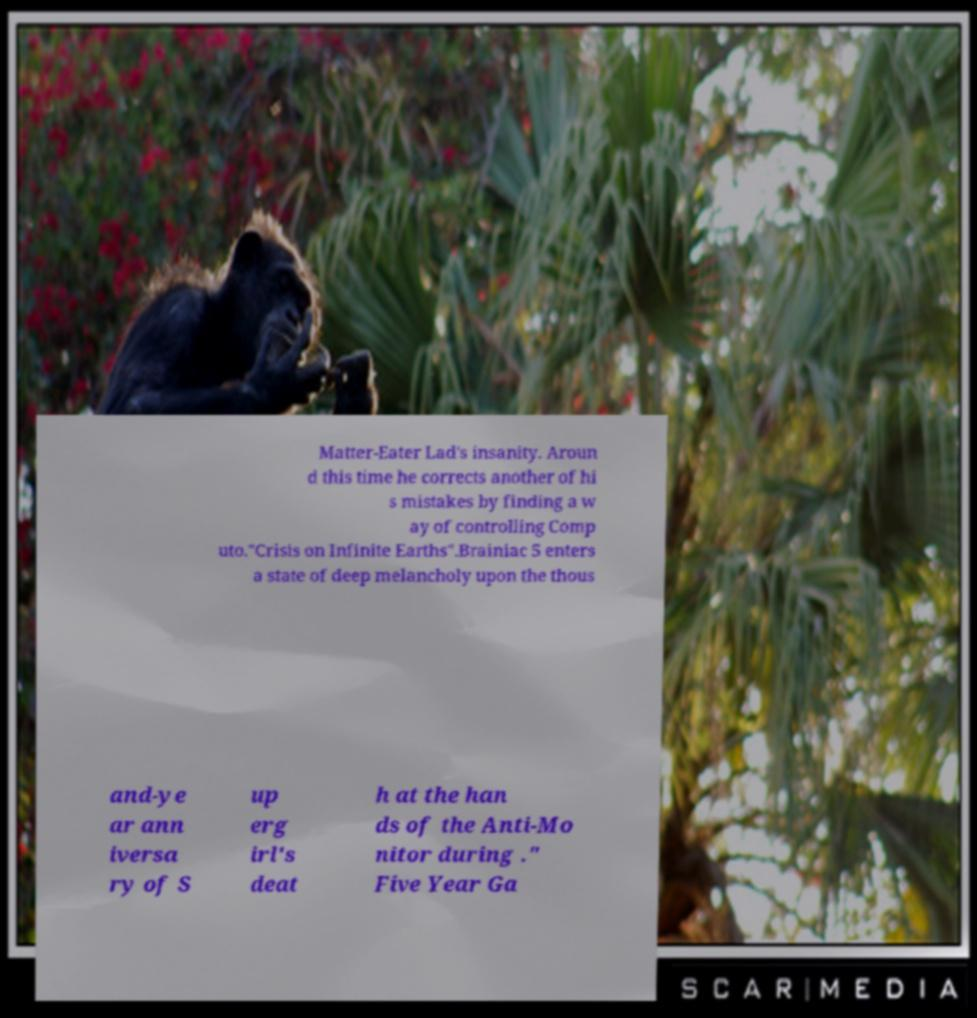Please identify and transcribe the text found in this image. Matter-Eater Lad's insanity. Aroun d this time he corrects another of hi s mistakes by finding a w ay of controlling Comp uto."Crisis on Infinite Earths".Brainiac 5 enters a state of deep melancholy upon the thous and-ye ar ann iversa ry of S up erg irl's deat h at the han ds of the Anti-Mo nitor during ." Five Year Ga 